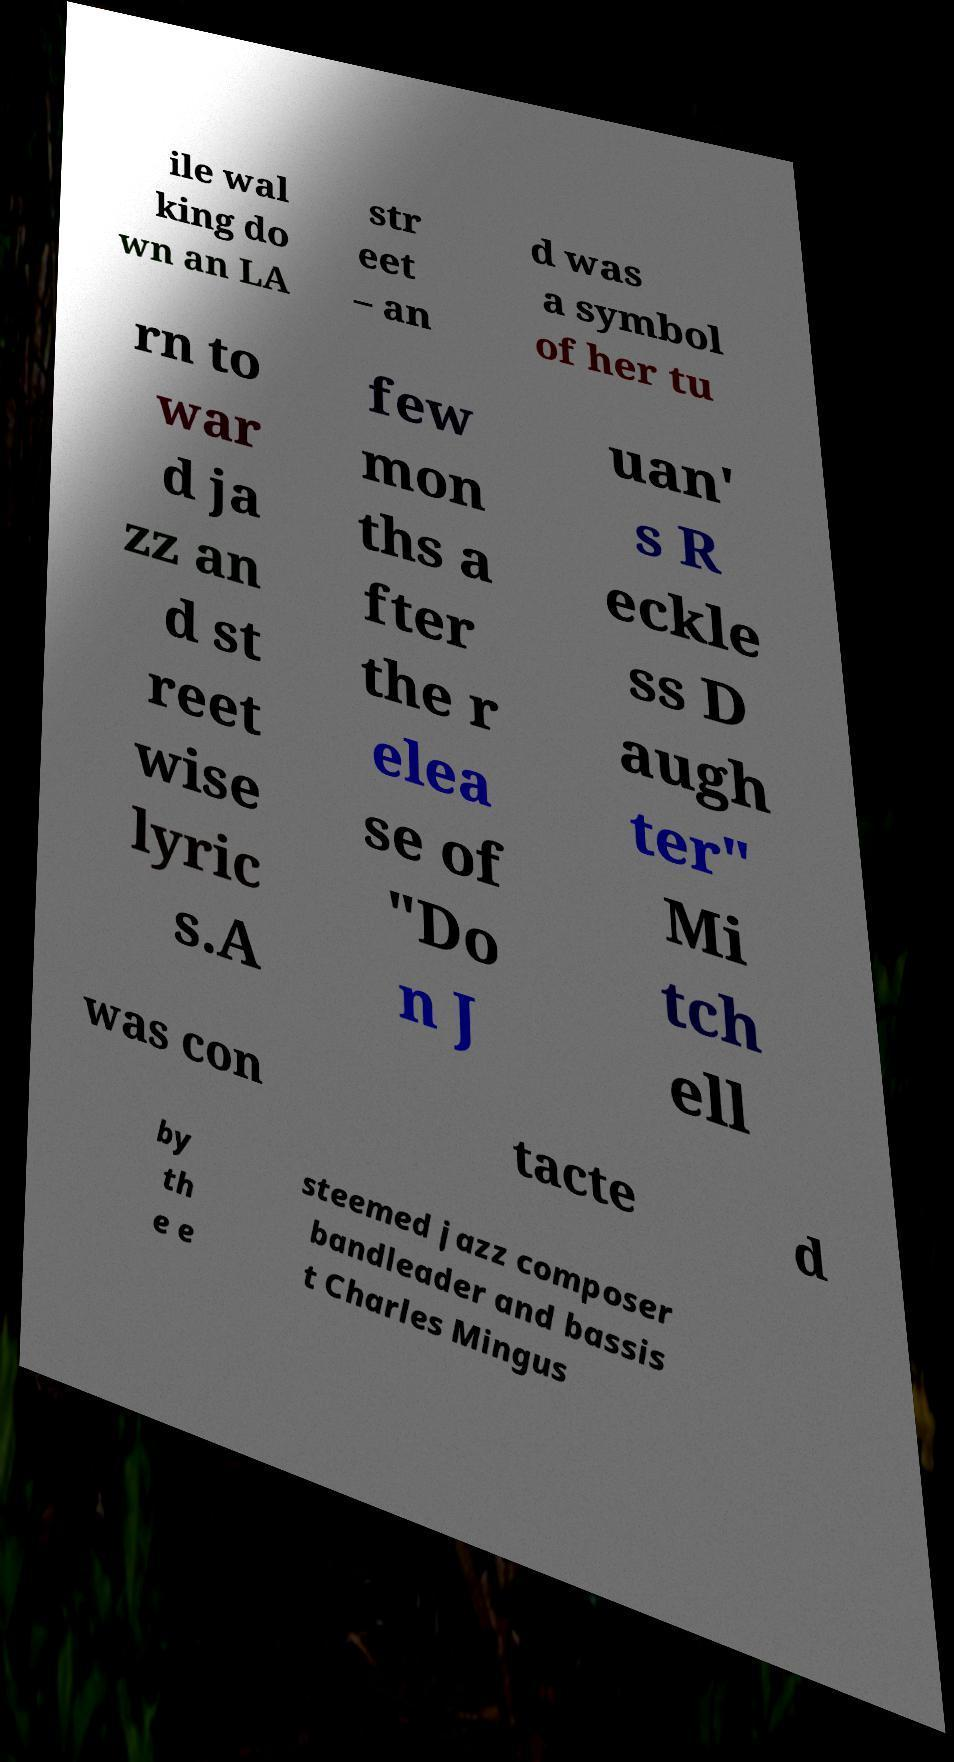Please identify and transcribe the text found in this image. ile wal king do wn an LA str eet – an d was a symbol of her tu rn to war d ja zz an d st reet wise lyric s.A few mon ths a fter the r elea se of "Do n J uan' s R eckle ss D augh ter" Mi tch ell was con tacte d by th e e steemed jazz composer bandleader and bassis t Charles Mingus 